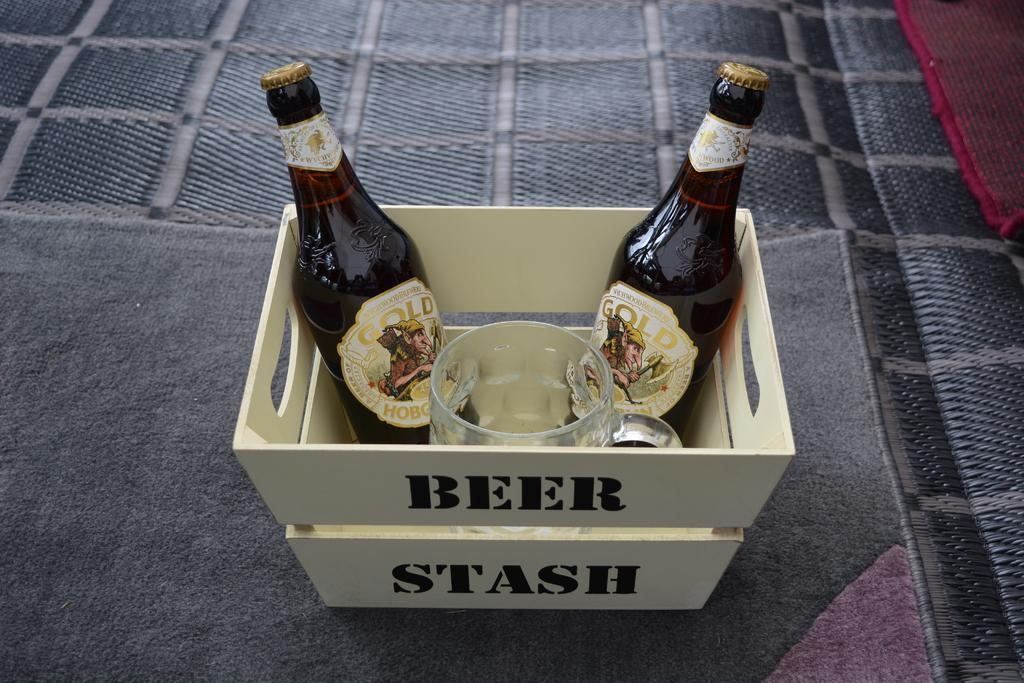<image>
Share a concise interpretation of the image provided. the words beer stash are on a box 